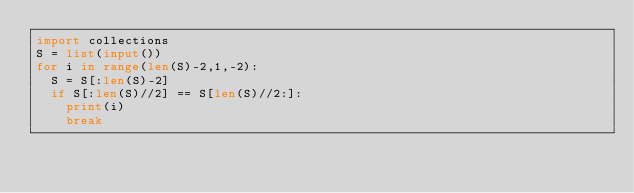<code> <loc_0><loc_0><loc_500><loc_500><_Python_>import collections
S = list(input())
for i in range(len(S)-2,1,-2):
  S = S[:len(S)-2]
  if S[:len(S)//2] == S[len(S)//2:]:
    print(i)
    break</code> 